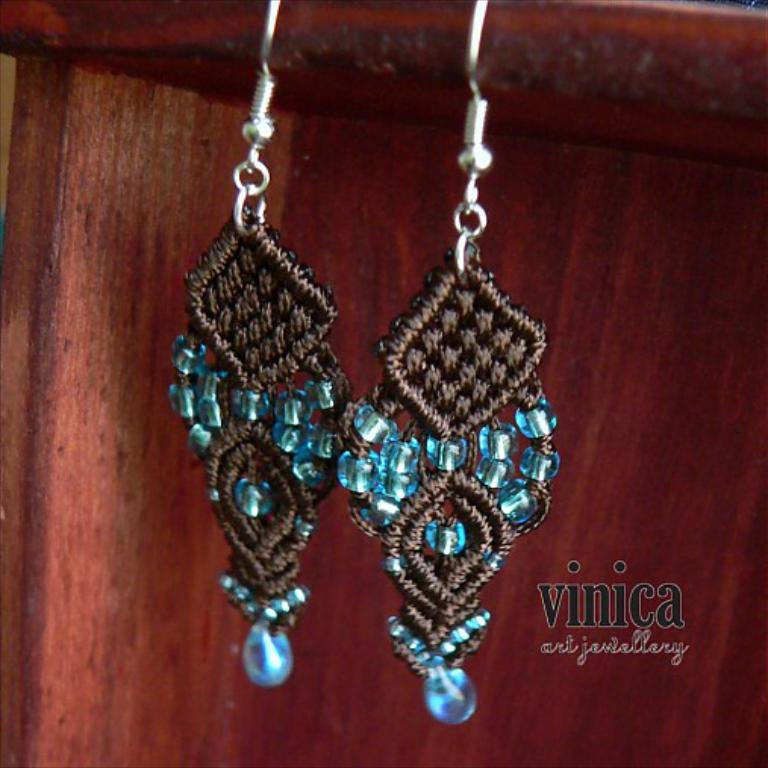What type of jewelry is featured in the image? There are two earrings in the image. What colors are present in the earrings? The earrings are black, blue, and silver in color. What can be seen in the background of the image? The background of the image is brown. What type of crown is worn by the company's mascot in the image? There is no crown or company mascot present in the image; it features two earrings. How does the skate interact with the earrings in the image? There is no skate present in the image; it only features earrings and a brown background. 